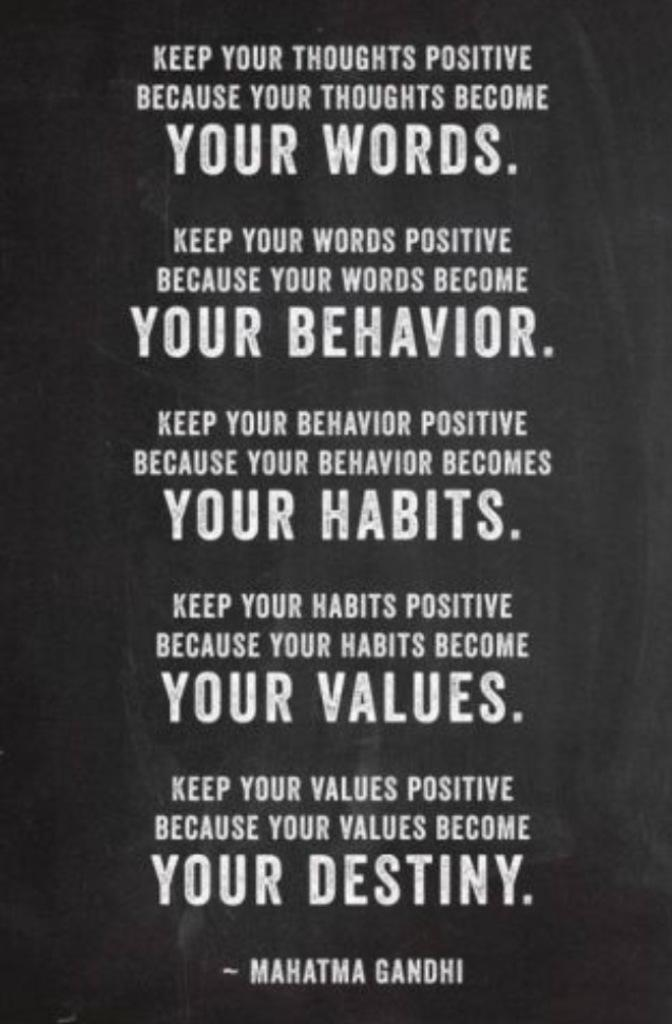<image>
Summarize the visual content of the image. Sign that has quotes from Mahatma Gandhi including one about Destiny. 